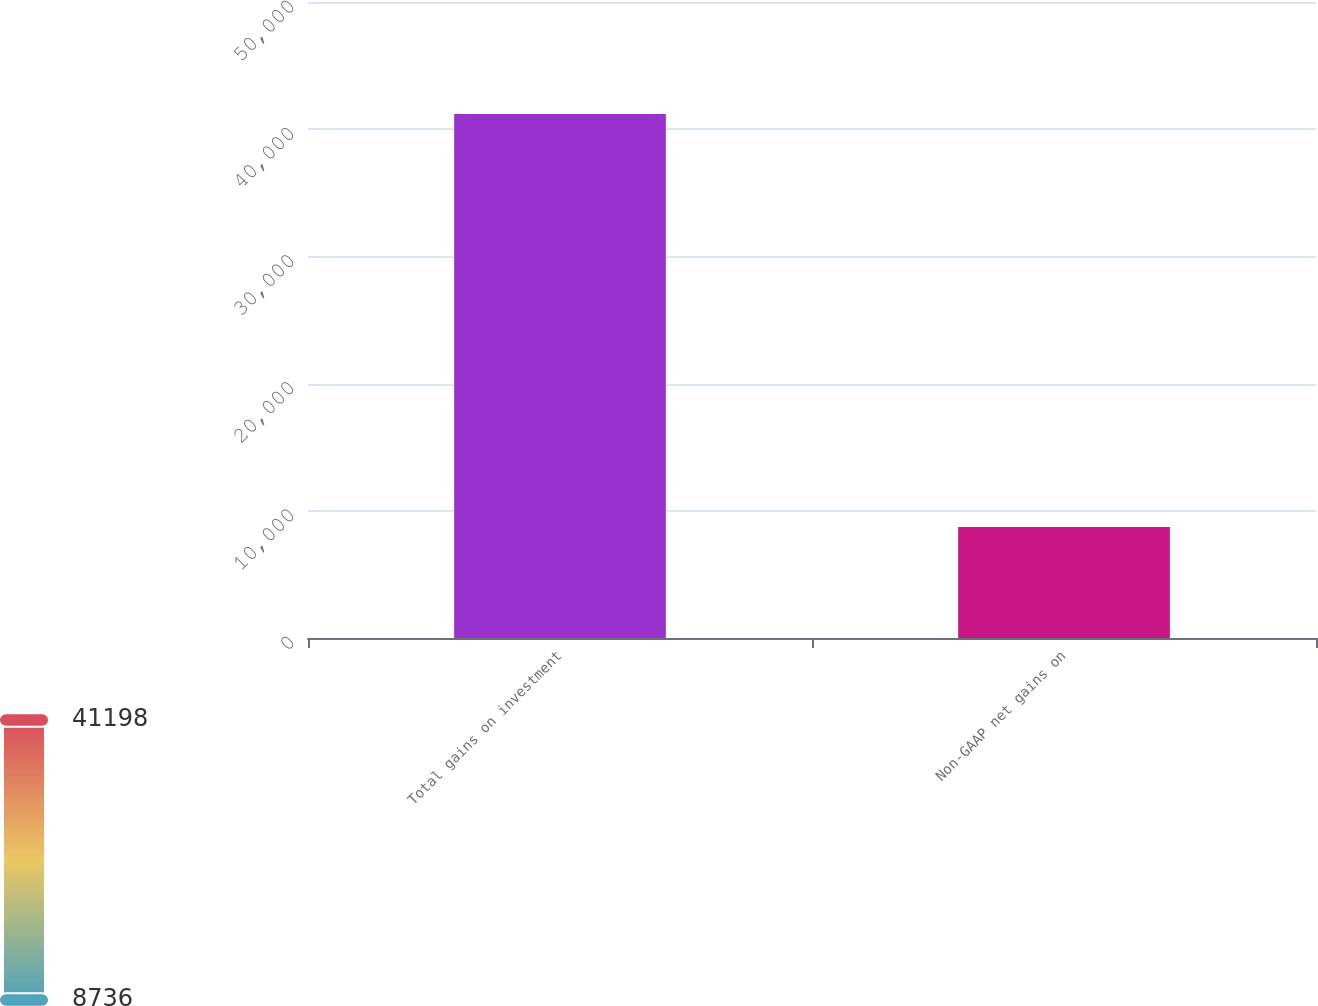<chart> <loc_0><loc_0><loc_500><loc_500><bar_chart><fcel>Total gains on investment<fcel>Non-GAAP net gains on<nl><fcel>41198<fcel>8735.9<nl></chart> 